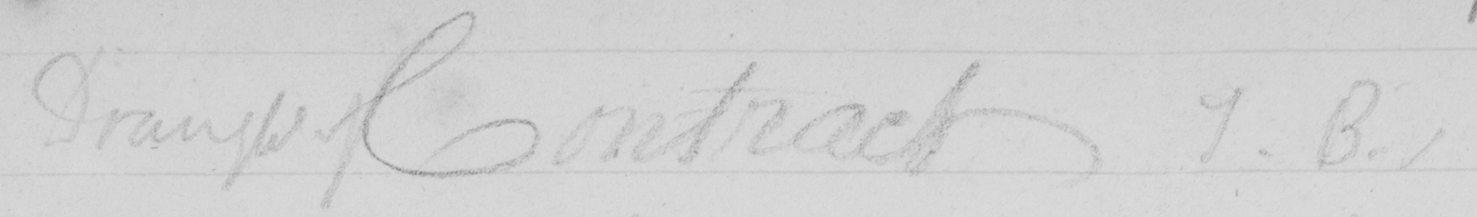Can you tell me what this handwritten text says? Draught Contract J.B . 